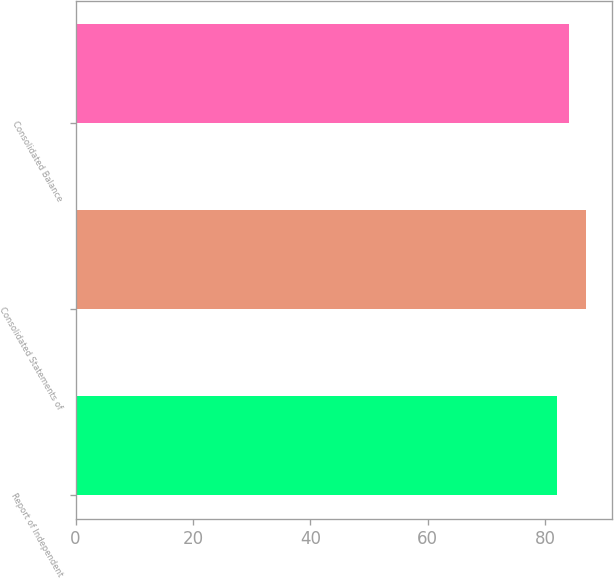Convert chart. <chart><loc_0><loc_0><loc_500><loc_500><bar_chart><fcel>Report of Independent<fcel>Consolidated Statements of<fcel>Consolidated Balance<nl><fcel>82<fcel>87<fcel>84<nl></chart> 